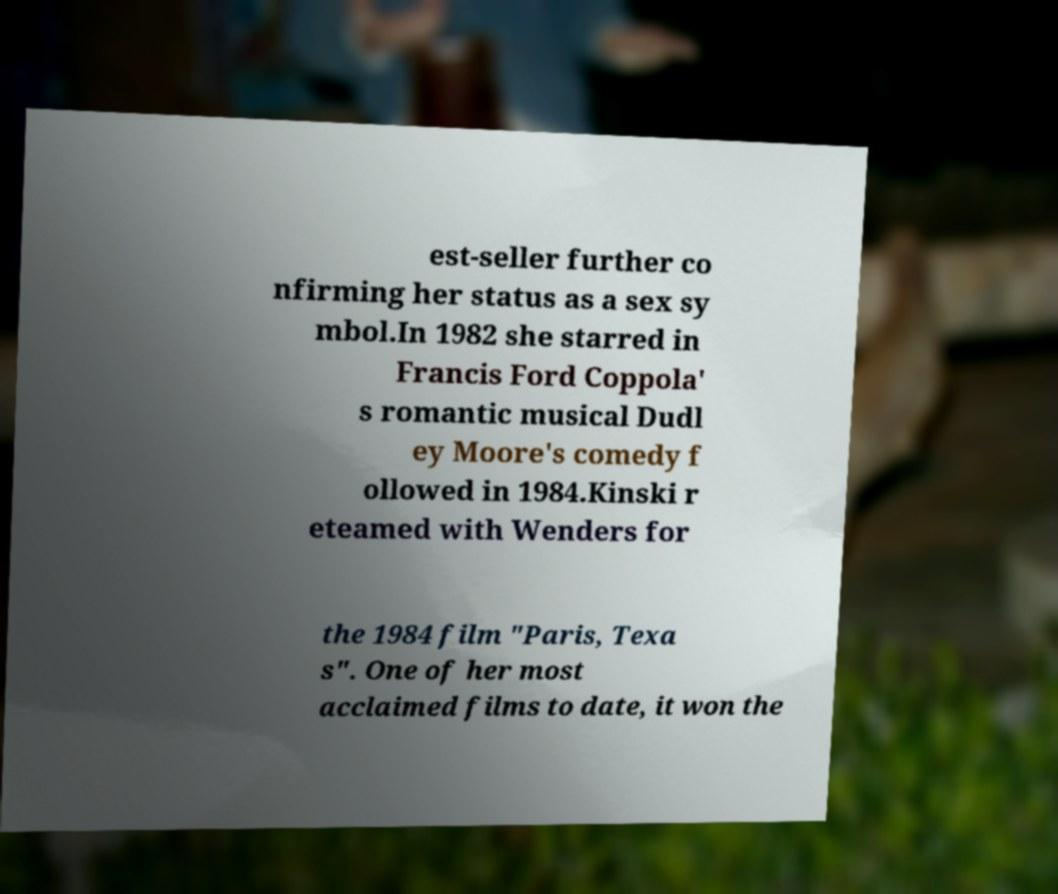Please read and relay the text visible in this image. What does it say? est-seller further co nfirming her status as a sex sy mbol.In 1982 she starred in Francis Ford Coppola' s romantic musical Dudl ey Moore's comedy f ollowed in 1984.Kinski r eteamed with Wenders for the 1984 film "Paris, Texa s". One of her most acclaimed films to date, it won the 